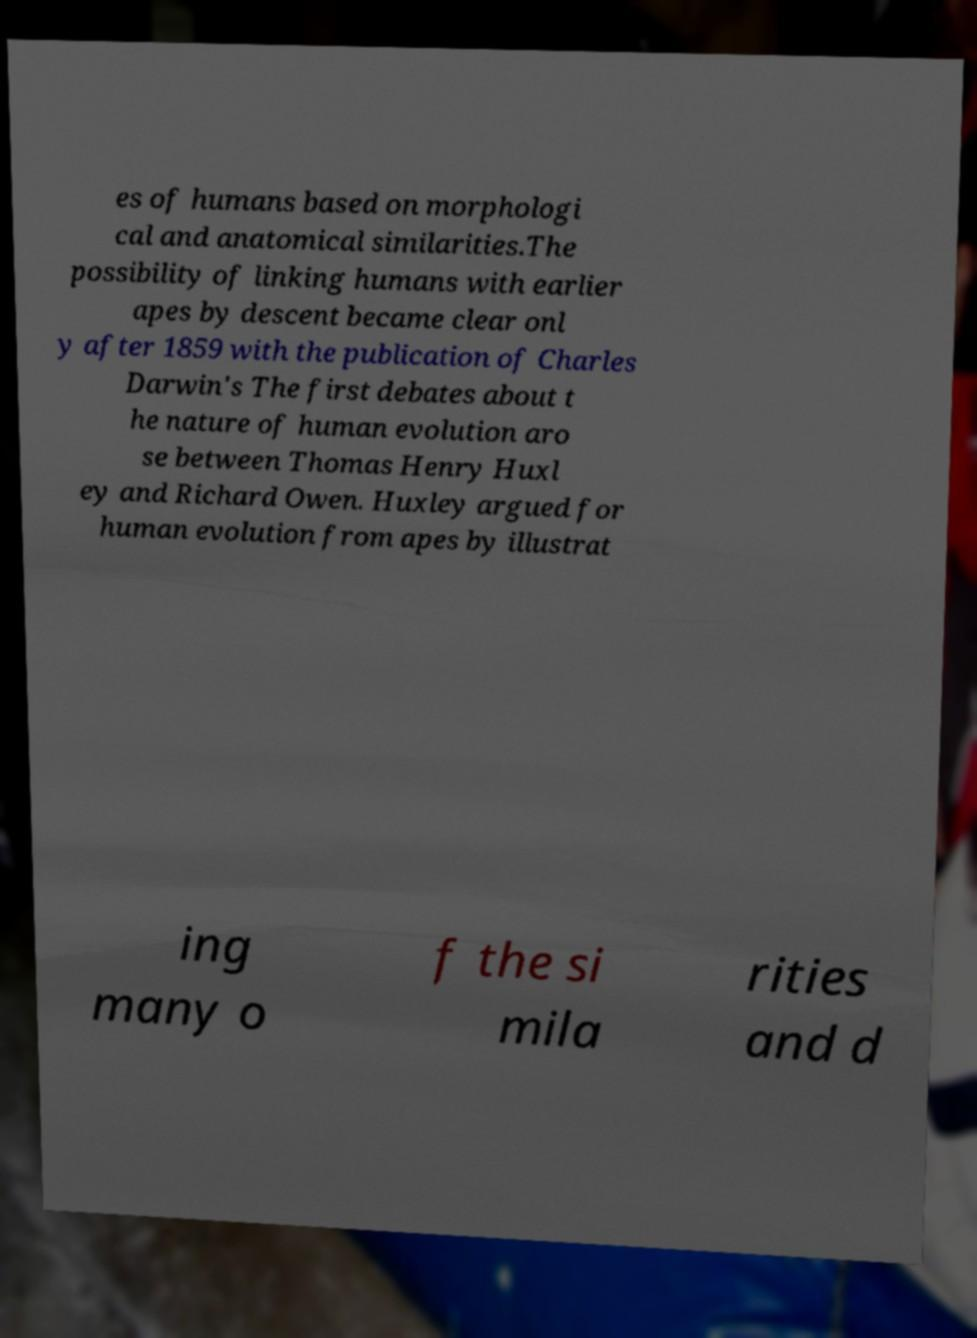Please identify and transcribe the text found in this image. es of humans based on morphologi cal and anatomical similarities.The possibility of linking humans with earlier apes by descent became clear onl y after 1859 with the publication of Charles Darwin's The first debates about t he nature of human evolution aro se between Thomas Henry Huxl ey and Richard Owen. Huxley argued for human evolution from apes by illustrat ing many o f the si mila rities and d 